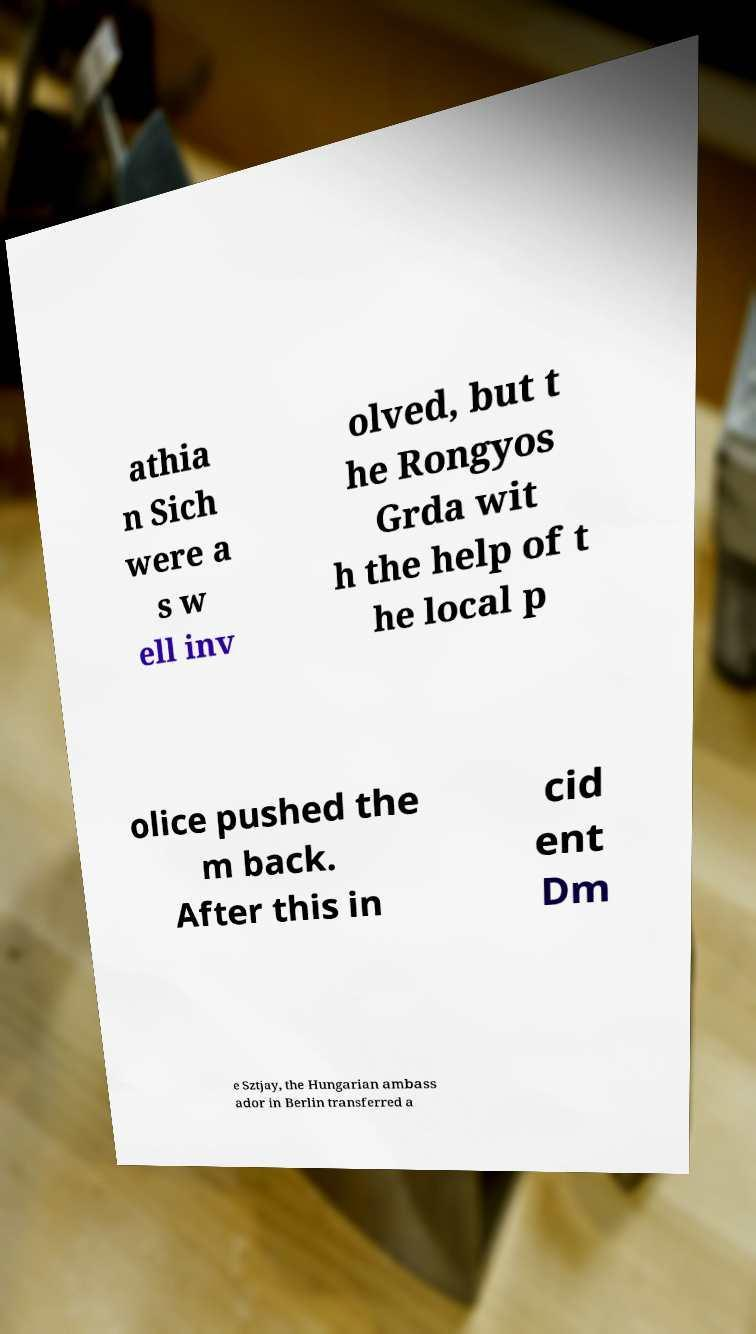What messages or text are displayed in this image? I need them in a readable, typed format. athia n Sich were a s w ell inv olved, but t he Rongyos Grda wit h the help of t he local p olice pushed the m back. After this in cid ent Dm e Sztjay, the Hungarian ambass ador in Berlin transferred a 